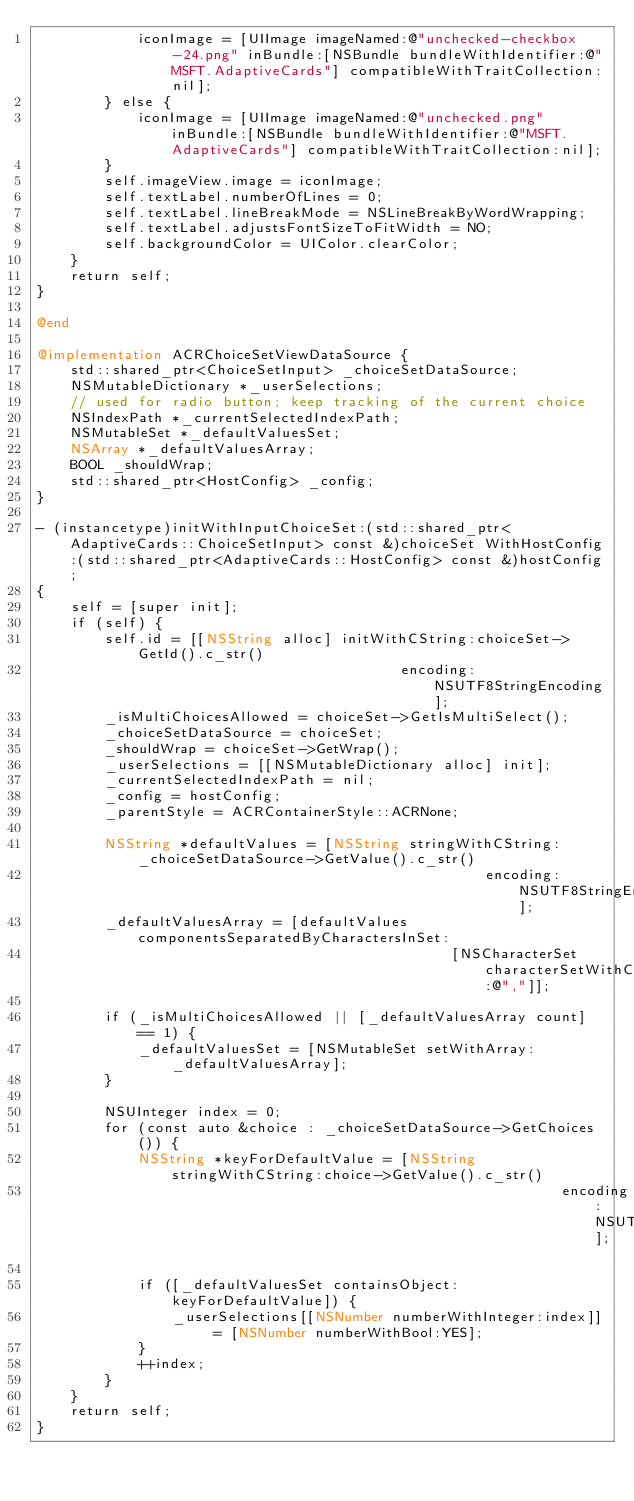Convert code to text. <code><loc_0><loc_0><loc_500><loc_500><_ObjectiveC_>            iconImage = [UIImage imageNamed:@"unchecked-checkbox-24.png" inBundle:[NSBundle bundleWithIdentifier:@"MSFT.AdaptiveCards"] compatibleWithTraitCollection:nil];
        } else {
            iconImage = [UIImage imageNamed:@"unchecked.png" inBundle:[NSBundle bundleWithIdentifier:@"MSFT.AdaptiveCards"] compatibleWithTraitCollection:nil];
        }
        self.imageView.image = iconImage;
        self.textLabel.numberOfLines = 0;
        self.textLabel.lineBreakMode = NSLineBreakByWordWrapping;
        self.textLabel.adjustsFontSizeToFitWidth = NO;
        self.backgroundColor = UIColor.clearColor;
    }
    return self;
}

@end

@implementation ACRChoiceSetViewDataSource {
    std::shared_ptr<ChoiceSetInput> _choiceSetDataSource;
    NSMutableDictionary *_userSelections;
    // used for radio button; keep tracking of the current choice
    NSIndexPath *_currentSelectedIndexPath;
    NSMutableSet *_defaultValuesSet;
    NSArray *_defaultValuesArray;
    BOOL _shouldWrap;
    std::shared_ptr<HostConfig> _config;
}

- (instancetype)initWithInputChoiceSet:(std::shared_ptr<AdaptiveCards::ChoiceSetInput> const &)choiceSet WithHostConfig:(std::shared_ptr<AdaptiveCards::HostConfig> const &)hostConfig;
{
    self = [super init];
    if (self) {
        self.id = [[NSString alloc] initWithCString:choiceSet->GetId().c_str()
                                           encoding:NSUTF8StringEncoding];
        _isMultiChoicesAllowed = choiceSet->GetIsMultiSelect();
        _choiceSetDataSource = choiceSet;
        _shouldWrap = choiceSet->GetWrap();
        _userSelections = [[NSMutableDictionary alloc] init];
        _currentSelectedIndexPath = nil;
        _config = hostConfig;
        _parentStyle = ACRContainerStyle::ACRNone;

        NSString *defaultValues = [NSString stringWithCString:_choiceSetDataSource->GetValue().c_str()
                                                     encoding:NSUTF8StringEncoding];
        _defaultValuesArray = [defaultValues componentsSeparatedByCharactersInSet:
                                                 [NSCharacterSet characterSetWithCharactersInString:@","]];

        if (_isMultiChoicesAllowed || [_defaultValuesArray count] == 1) {
            _defaultValuesSet = [NSMutableSet setWithArray:_defaultValuesArray];
        }

        NSUInteger index = 0;
        for (const auto &choice : _choiceSetDataSource->GetChoices()) {
            NSString *keyForDefaultValue = [NSString stringWithCString:choice->GetValue().c_str()
                                                              encoding:NSUTF8StringEncoding];

            if ([_defaultValuesSet containsObject:keyForDefaultValue]) {
                _userSelections[[NSNumber numberWithInteger:index]] = [NSNumber numberWithBool:YES];
            }
            ++index;
        }
    }
    return self;
}
</code> 